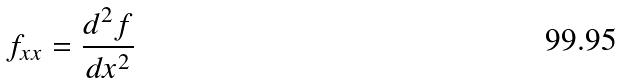Convert formula to latex. <formula><loc_0><loc_0><loc_500><loc_500>f _ { x x } = \frac { d ^ { 2 } f } { d x ^ { 2 } }</formula> 